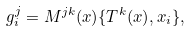<formula> <loc_0><loc_0><loc_500><loc_500>g ^ { j } _ { i } = M ^ { j k } ( x ) \{ T ^ { k } ( x ) , x _ { i } \} ,</formula> 